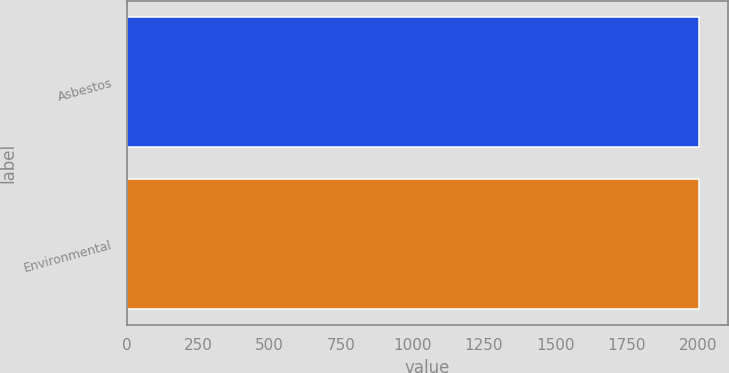<chart> <loc_0><loc_0><loc_500><loc_500><bar_chart><fcel>Asbestos<fcel>Environmental<nl><fcel>2003<fcel>2003.1<nl></chart> 